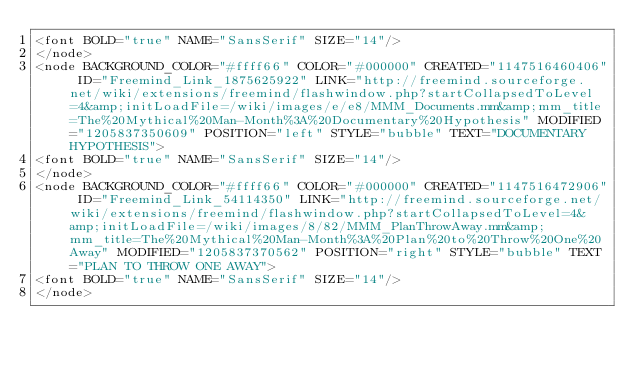Convert code to text. <code><loc_0><loc_0><loc_500><loc_500><_ObjectiveC_><font BOLD="true" NAME="SansSerif" SIZE="14"/>
</node>
<node BACKGROUND_COLOR="#ffff66" COLOR="#000000" CREATED="1147516460406" ID="Freemind_Link_1875625922" LINK="http://freemind.sourceforge.net/wiki/extensions/freemind/flashwindow.php?startCollapsedToLevel=4&amp;initLoadFile=/wiki/images/e/e8/MMM_Documents.mm&amp;mm_title=The%20Mythical%20Man-Month%3A%20Documentary%20Hypothesis" MODIFIED="1205837350609" POSITION="left" STYLE="bubble" TEXT="DOCUMENTARY HYPOTHESIS">
<font BOLD="true" NAME="SansSerif" SIZE="14"/>
</node>
<node BACKGROUND_COLOR="#ffff66" COLOR="#000000" CREATED="1147516472906" ID="Freemind_Link_54114350" LINK="http://freemind.sourceforge.net/wiki/extensions/freemind/flashwindow.php?startCollapsedToLevel=4&amp;initLoadFile=/wiki/images/8/82/MMM_PlanThrowAway.mm&amp;mm_title=The%20Mythical%20Man-Month%3A%20Plan%20to%20Throw%20One%20Away" MODIFIED="1205837370562" POSITION="right" STYLE="bubble" TEXT="PLAN TO THROW ONE AWAY">
<font BOLD="true" NAME="SansSerif" SIZE="14"/>
</node></code> 